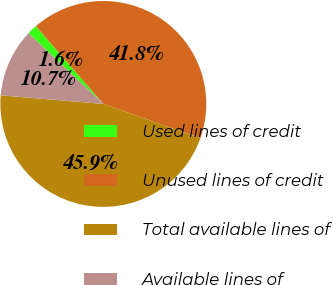Convert chart to OTSL. <chart><loc_0><loc_0><loc_500><loc_500><pie_chart><fcel>Used lines of credit<fcel>Unused lines of credit<fcel>Total available lines of<fcel>Available lines of<nl><fcel>1.57%<fcel>41.77%<fcel>45.94%<fcel>10.72%<nl></chart> 